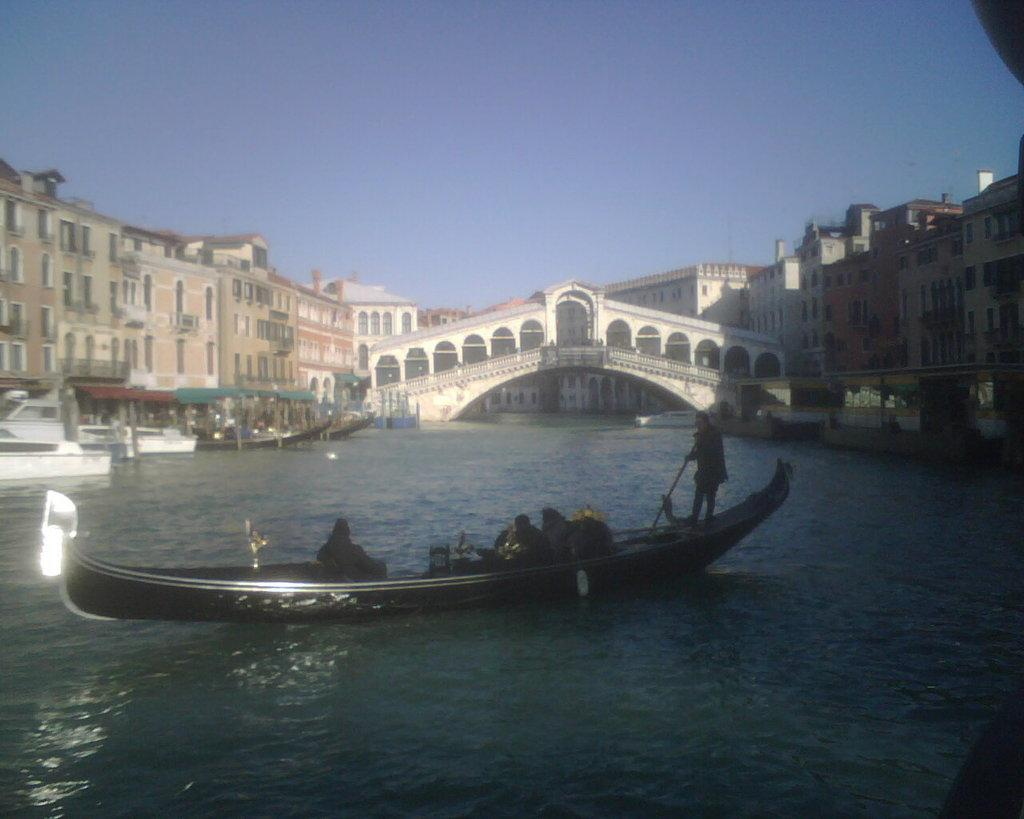What is the main element in the image? There is water in the image. What is present in the water? There are boats in the water. Who or what can be seen in the image? There are people visible in the image. What can be seen in the distance in the image? There are buildings in the background of the image, and the sky is visible in the background as well. What type of boundary can be seen on the edge of the water in the image? There is no boundary visible on the edge of the water in the image. 